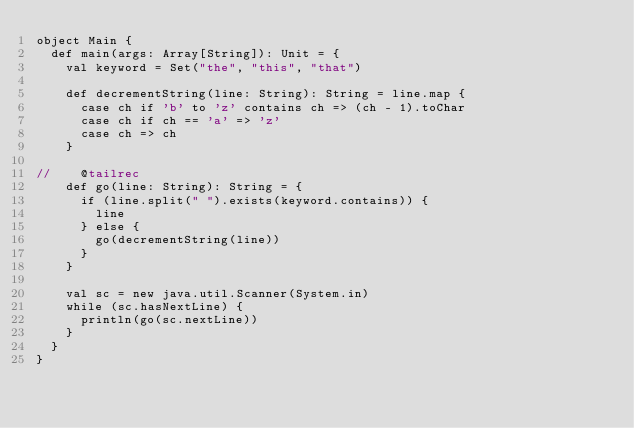<code> <loc_0><loc_0><loc_500><loc_500><_Scala_>object Main {
  def main(args: Array[String]): Unit = {
    val keyword = Set("the", "this", "that")

    def decrementString(line: String): String = line.map {
      case ch if 'b' to 'z' contains ch => (ch - 1).toChar
      case ch if ch == 'a' => 'z'
      case ch => ch
    }

//    @tailrec
    def go(line: String): String = {
      if (line.split(" ").exists(keyword.contains)) {
        line
      } else {
        go(decrementString(line))
      }
    }

    val sc = new java.util.Scanner(System.in)
    while (sc.hasNextLine) {
      println(go(sc.nextLine))
    }
  }
}</code> 